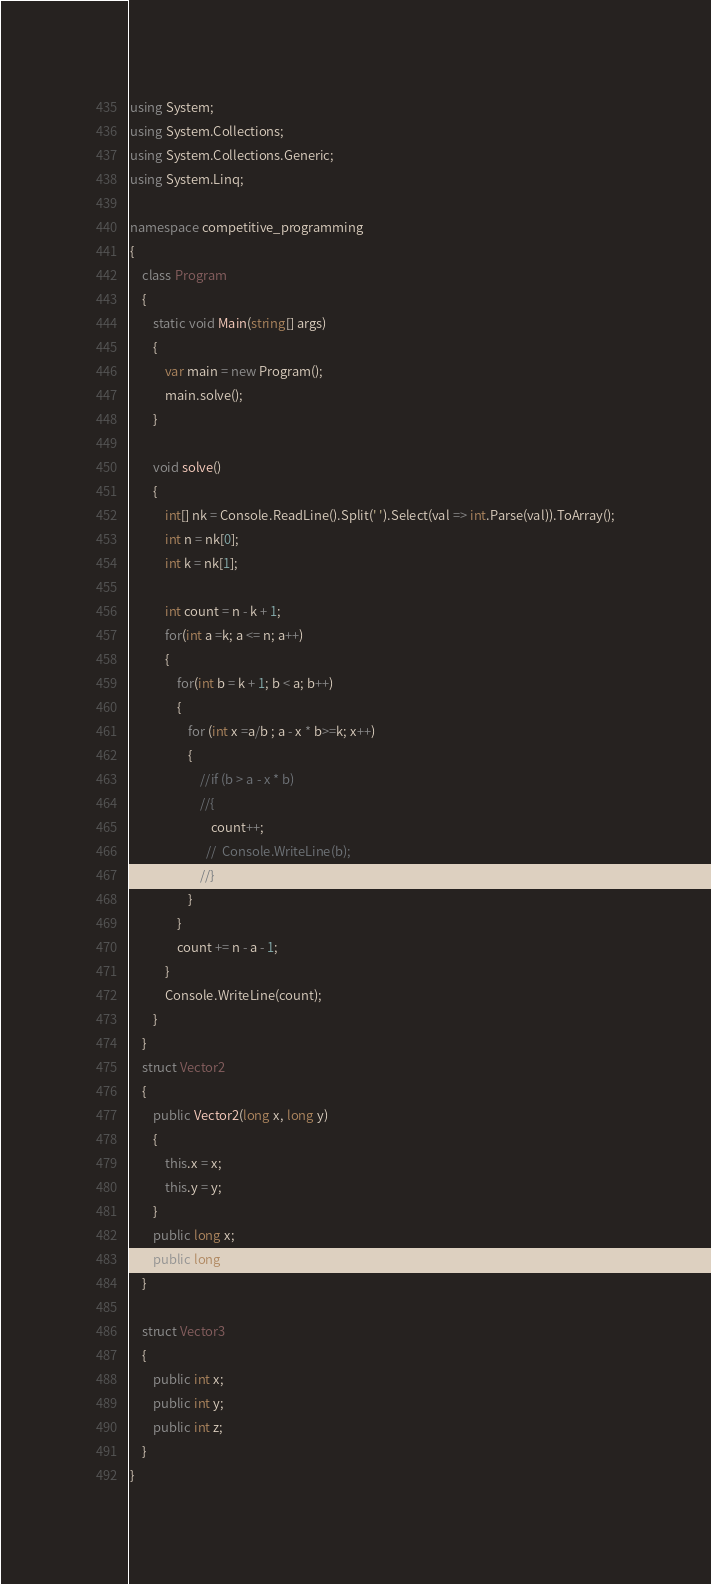Convert code to text. <code><loc_0><loc_0><loc_500><loc_500><_C#_>using System;
using System.Collections;
using System.Collections.Generic;
using System.Linq;

namespace competitive_programming
{
    class Program
    {
        static void Main(string[] args)
        {
            var main = new Program();
            main.solve();
        }

        void solve()
        {
            int[] nk = Console.ReadLine().Split(' ').Select(val => int.Parse(val)).ToArray();
            int n = nk[0];
            int k = nk[1];

            int count = n - k + 1;
            for(int a =k; a <= n; a++)
            {
                for(int b = k + 1; b < a; b++)
                {
                    for (int x =a/b ; a - x * b>=k; x++)
                    {
                        //if (b > a - x * b) 
                        //{
                            count++;
                          //  Console.WriteLine(b); 
                        //}
                    }
                }
                count += n - a - 1;
            }
            Console.WriteLine(count);
        }
    }
    struct Vector2
    {
        public Vector2(long x, long y)
        {
            this.x = x;
            this.y = y;
        }
        public long x;
        public long y;
    }

    struct Vector3
    {
        public int x;
        public int y;
        public int z;
    }
}
</code> 